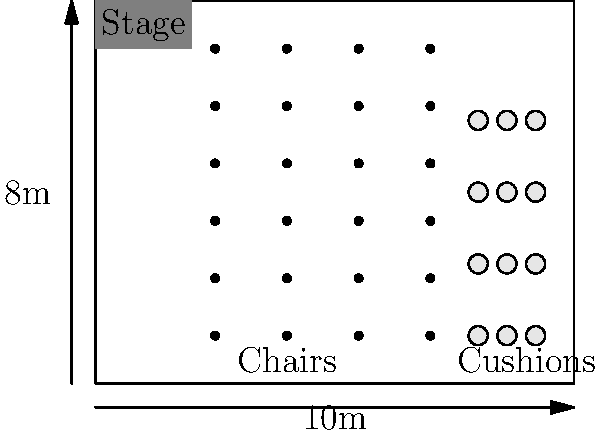Given the floor plan of your Buddhist center's main hall (10m x 8m) with a stage, chairs, and meditation cushions, what is the maximum number of attendees that can be accommodated while maintaining a 1.5m distance between individuals for social distancing? To solve this problem, we need to follow these steps:

1. Identify the available seating areas:
   - Chair area: 4 rows x 6 columns
   - Cushion area: 3 rows x 4 columns

2. Calculate the current capacity:
   - Chairs: 4 x 6 = 24 people
   - Cushions: 3 x 4 = 12 people
   - Total current capacity: 24 + 12 = 36 people

3. Apply social distancing rules:
   - We need to maintain a 1.5m distance between individuals
   - This means we can only use every other seat in both directions

4. Recalculate the capacity with social distancing:
   - Chairs: 
     * Rows: 4 ÷ 2 = 2 usable rows
     * Columns: 6 ÷ 2 = 3 usable columns
     * New chair capacity: 2 x 3 = 6 people
   - Cushions:
     * Rows: 3 ÷ 2 = 1 usable row (round down)
     * Columns: 4 ÷ 2 = 2 usable columns
     * New cushion capacity: 1 x 2 = 2 people

5. Calculate the total capacity with social distancing:
   - Total new capacity: 6 (chairs) + 2 (cushions) = 8 people

Therefore, the maximum number of attendees that can be accommodated while maintaining a 1.5m distance between individuals is 8 people.
Answer: 8 people 